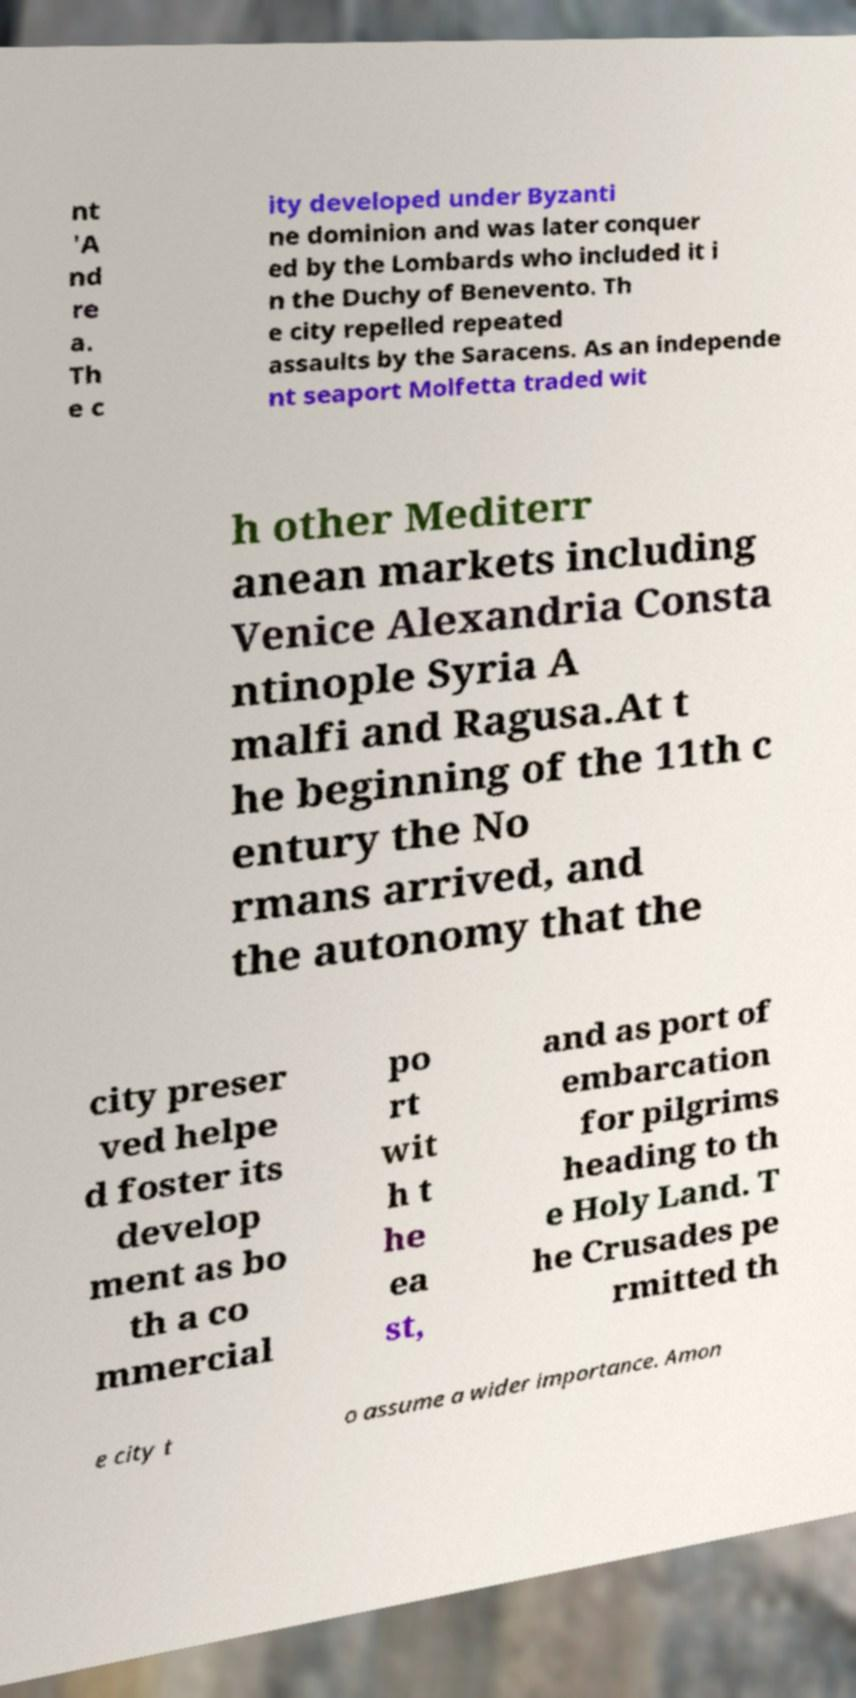For documentation purposes, I need the text within this image transcribed. Could you provide that? nt 'A nd re a. Th e c ity developed under Byzanti ne dominion and was later conquer ed by the Lombards who included it i n the Duchy of Benevento. Th e city repelled repeated assaults by the Saracens. As an independe nt seaport Molfetta traded wit h other Mediterr anean markets including Venice Alexandria Consta ntinople Syria A malfi and Ragusa.At t he beginning of the 11th c entury the No rmans arrived, and the autonomy that the city preser ved helpe d foster its develop ment as bo th a co mmercial po rt wit h t he ea st, and as port of embarcation for pilgrims heading to th e Holy Land. T he Crusades pe rmitted th e city t o assume a wider importance. Amon 